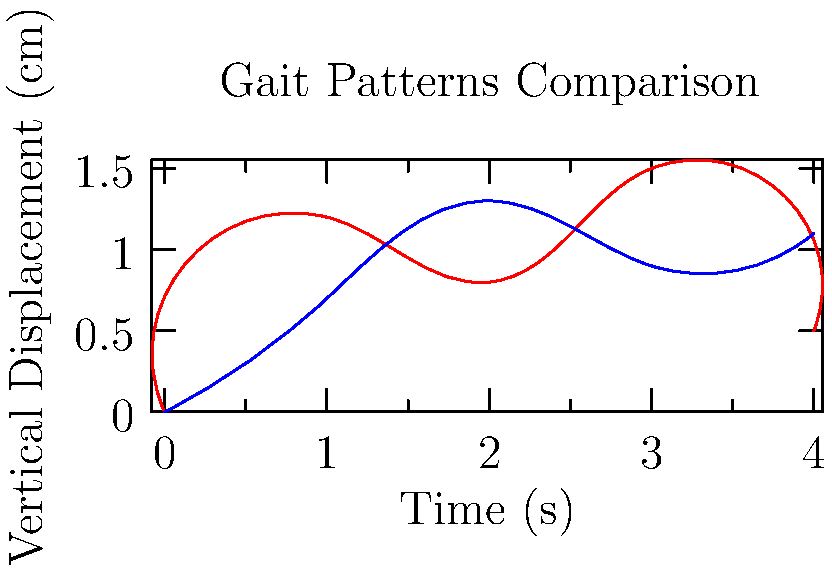Based on the graph comparing gait patterns from two different geographic regions, what cultural or environmental factors might contribute to the observed differences in vertical displacement during the walking cycle? To analyze the gait patterns and their potential cultural or environmental influences, we need to consider several factors:

1. Pattern differences:
   - Region A (red line) shows higher peaks and lower troughs, indicating a more pronounced up-and-down movement.
   - Region B (blue line) displays a more consistent, flatter pattern with less vertical displacement.

2. Cultural factors:
   - Walking pace: Region A's pattern suggests a slower, more deliberate gait, possibly influenced by cultural norms of unhurried movement or formal walking styles.
   - Body posture: The higher peaks in Region A might indicate a more upright posture, potentially linked to cultural emphasis on formality or status display.

3. Environmental factors:
   - Terrain: Region A's pattern could be adapted to uneven or hilly terrain, requiring more vertical movement for stability.
   - Climate: If Region A is colder, the higher peaks might result from a more energetic gait to generate body heat.

4. Footwear and clothing:
   - Region A's pattern might be influenced by traditional footwear (e.g., sandals or bare feet) that encourages a more pronounced heel-toe movement.
   - Region B's flatter pattern could result from shoes with more cushioning or restrictive clothing that limits vertical movement.

5. Body composition:
   - Differences in average height, weight, or body proportions between the regions could affect gait patterns.

6. Daily activities:
   - Region A's pattern might reflect adaptation to activities requiring more dynamic movement (e.g., frequent squatting or climbing).
   - Region B's pattern could be shaped by more sedentary lifestyles or extended periods of level walking.

The observed differences likely result from a combination of these factors, shaped by long-term cultural adaptations to specific environments and social norms.
Answer: Cultural norms, terrain, climate, footwear, body composition, and daily activities 